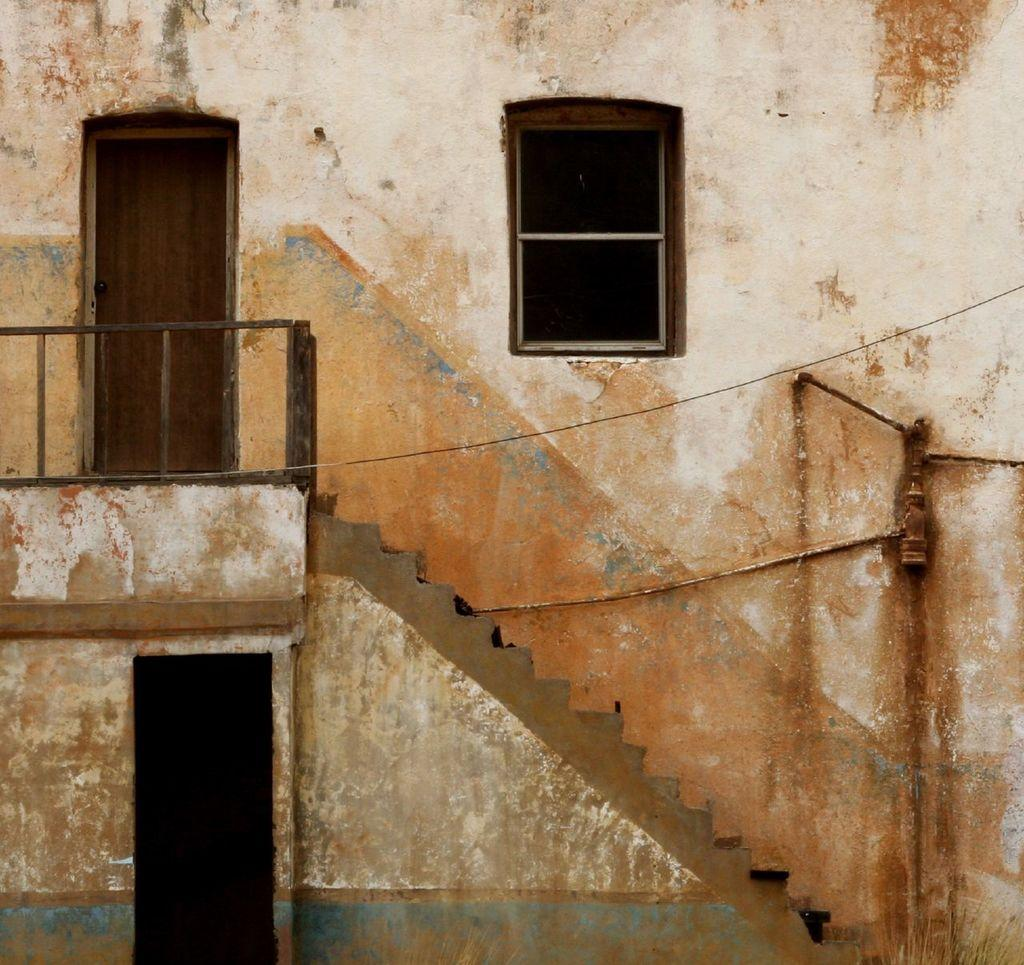What type of structure is depicted in the image? The image is of a building. What architectural feature can be seen in the building? There are iron grills in the building. What is a functional element found in the building? There is a staircase in the building. What are two common features of buildings that are present in this image? There is a door and a window in the building. How many snails can be seen crawling on the iron grills in the image? There are no snails present in the image; it only features a building with iron grills, a staircase, a door, and a window. 